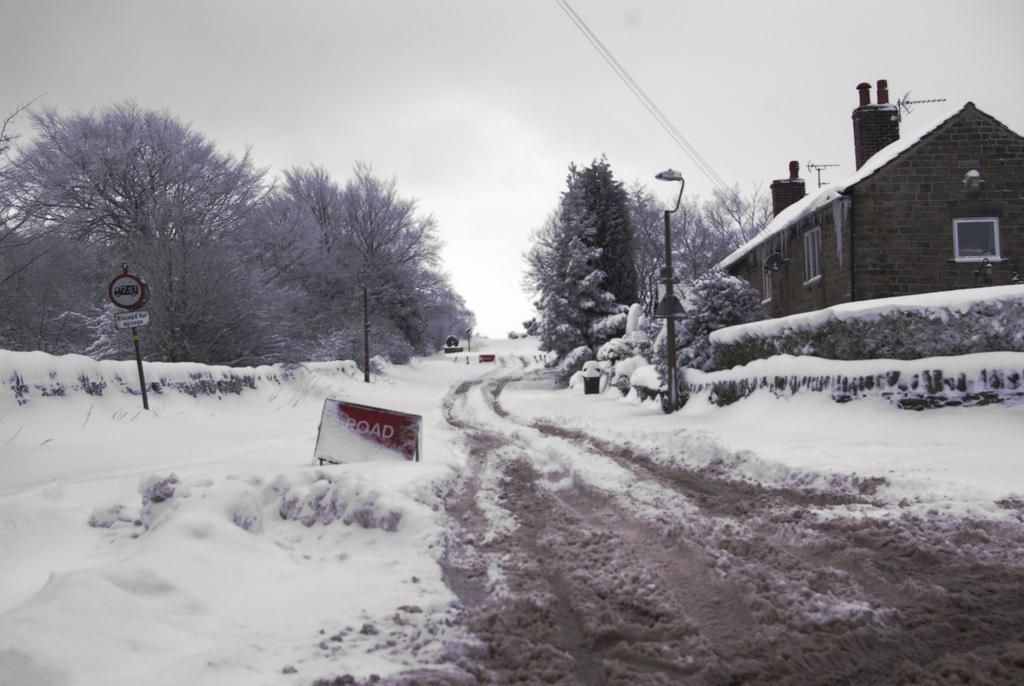How would you summarize this image in a sentence or two? There is a road. On the road there is snow. On the sides of the road there are trees, light pole, and a sign board with pole. On the right side there is a building. In the background there is sky. 